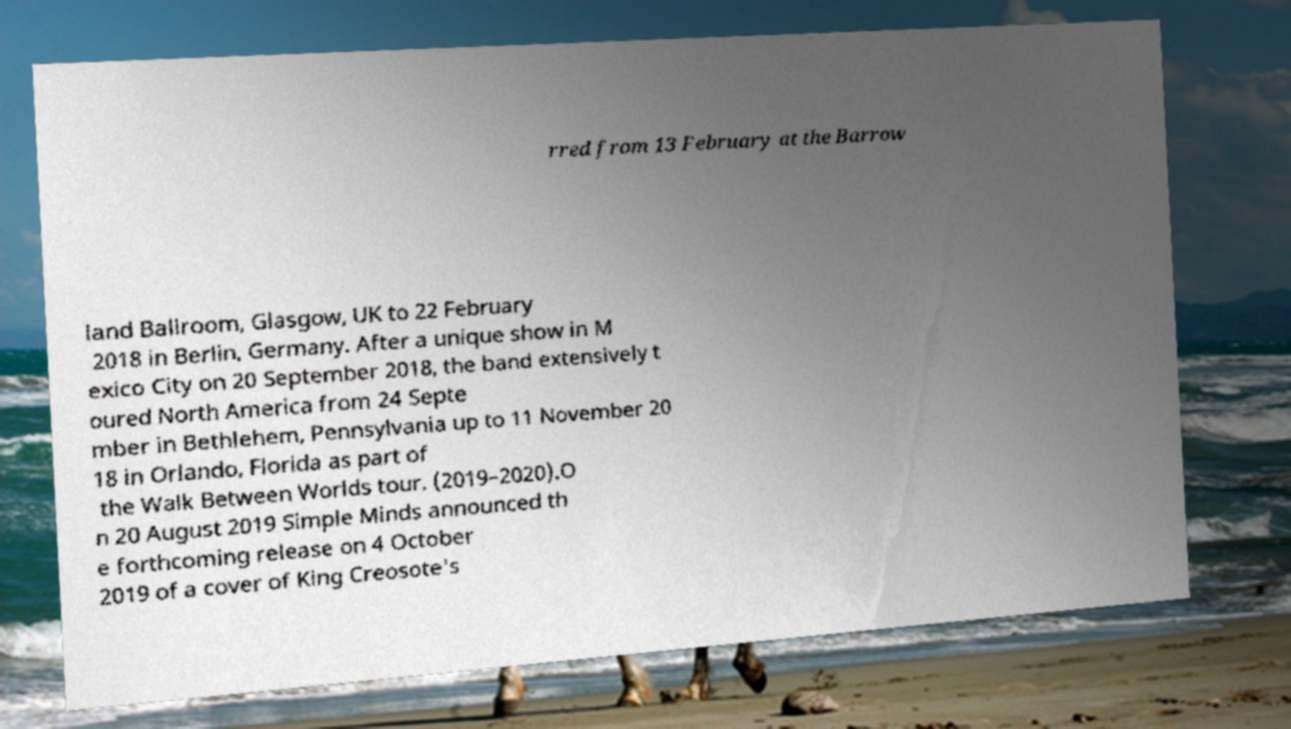For documentation purposes, I need the text within this image transcribed. Could you provide that? rred from 13 February at the Barrow land Ballroom, Glasgow, UK to 22 February 2018 in Berlin, Germany. After a unique show in M exico City on 20 September 2018, the band extensively t oured North America from 24 Septe mber in Bethlehem, Pennsylvania up to 11 November 20 18 in Orlando, Florida as part of the Walk Between Worlds tour. (2019–2020).O n 20 August 2019 Simple Minds announced th e forthcoming release on 4 October 2019 of a cover of King Creosote's 